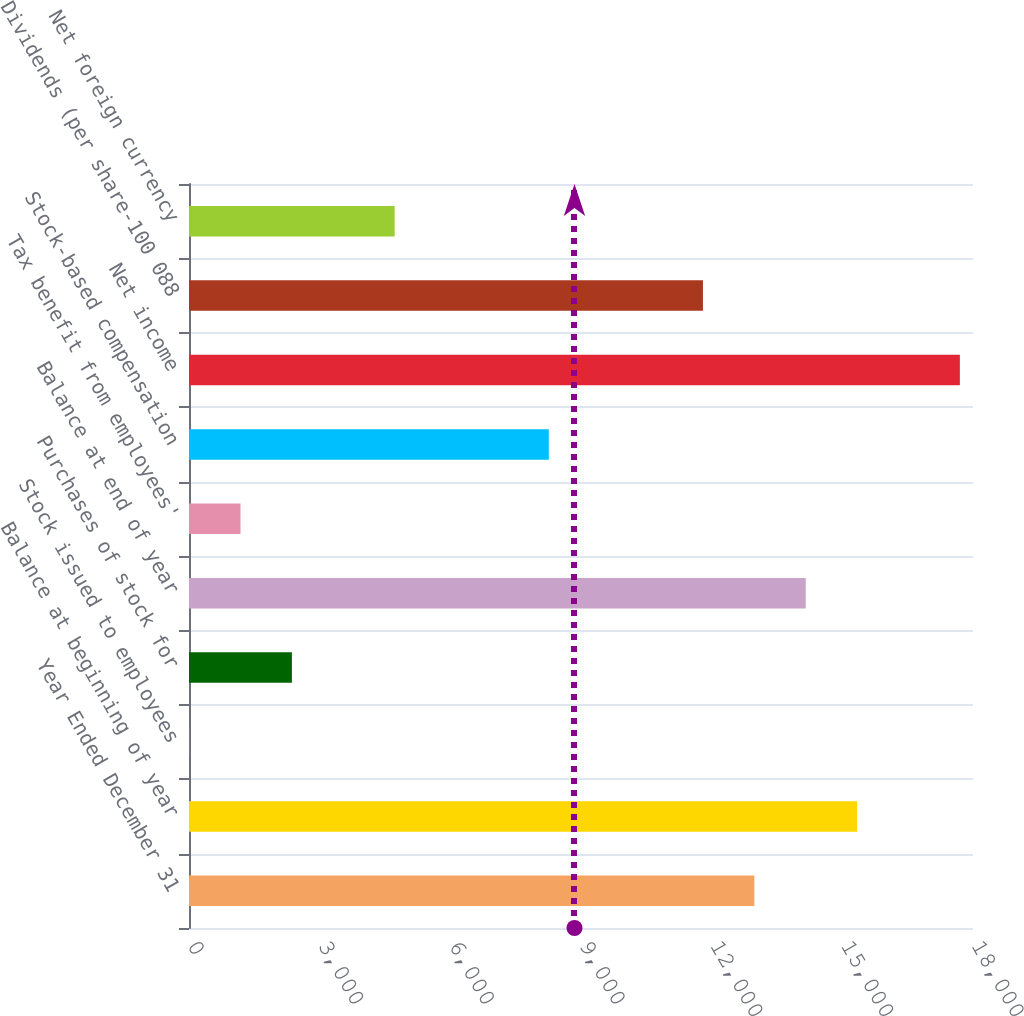Convert chart. <chart><loc_0><loc_0><loc_500><loc_500><bar_chart><fcel>Year Ended December 31<fcel>Balance at beginning of year<fcel>Stock issued to employees<fcel>Purchases of stock for<fcel>Balance at end of year<fcel>Tax benefit from employees'<fcel>Stock-based compensation<fcel>Net income<fcel>Dividends (per share-100 088<fcel>Net foreign currency<nl><fcel>12979.7<fcel>15339.1<fcel>3<fcel>2362.4<fcel>14159.4<fcel>1182.7<fcel>8260.9<fcel>17698.5<fcel>11800<fcel>4721.8<nl></chart> 